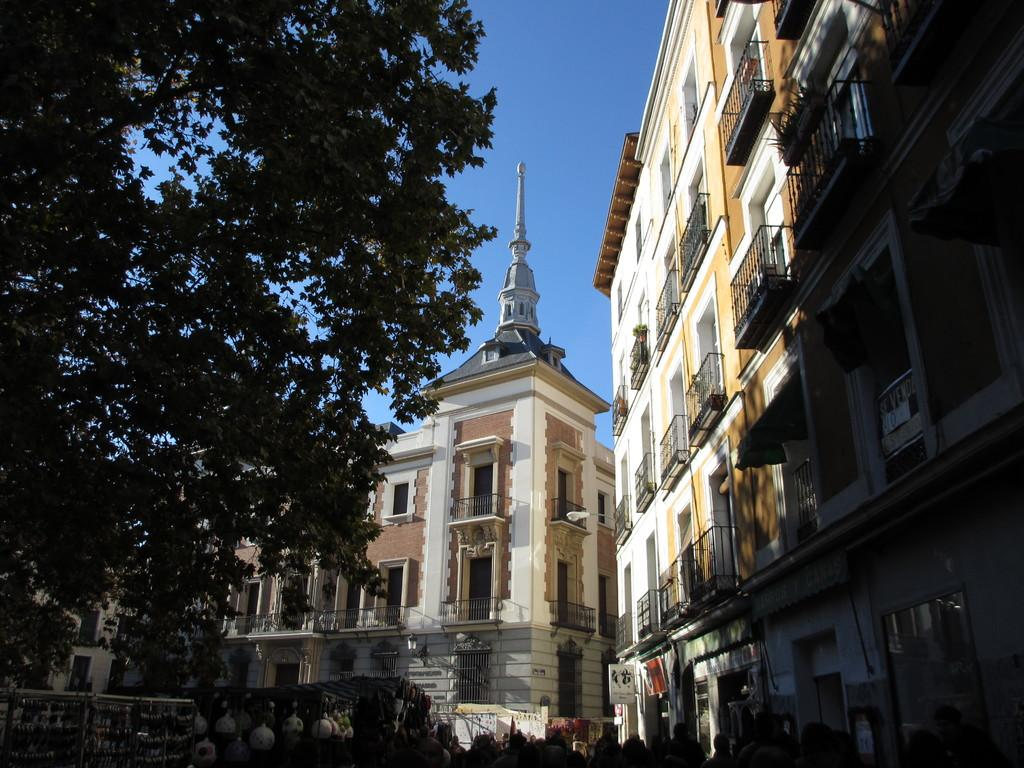What types of structures are present in the image? There are multiple buildings in the image. Are there any natural elements present in the image? Yes, there is a tree in the image. What can be seen in the sky in the image? The sky is clear and visible in the image. What type of cloth is draped over the daughter's head in the image? There is no daughter or cloth present in the image. 